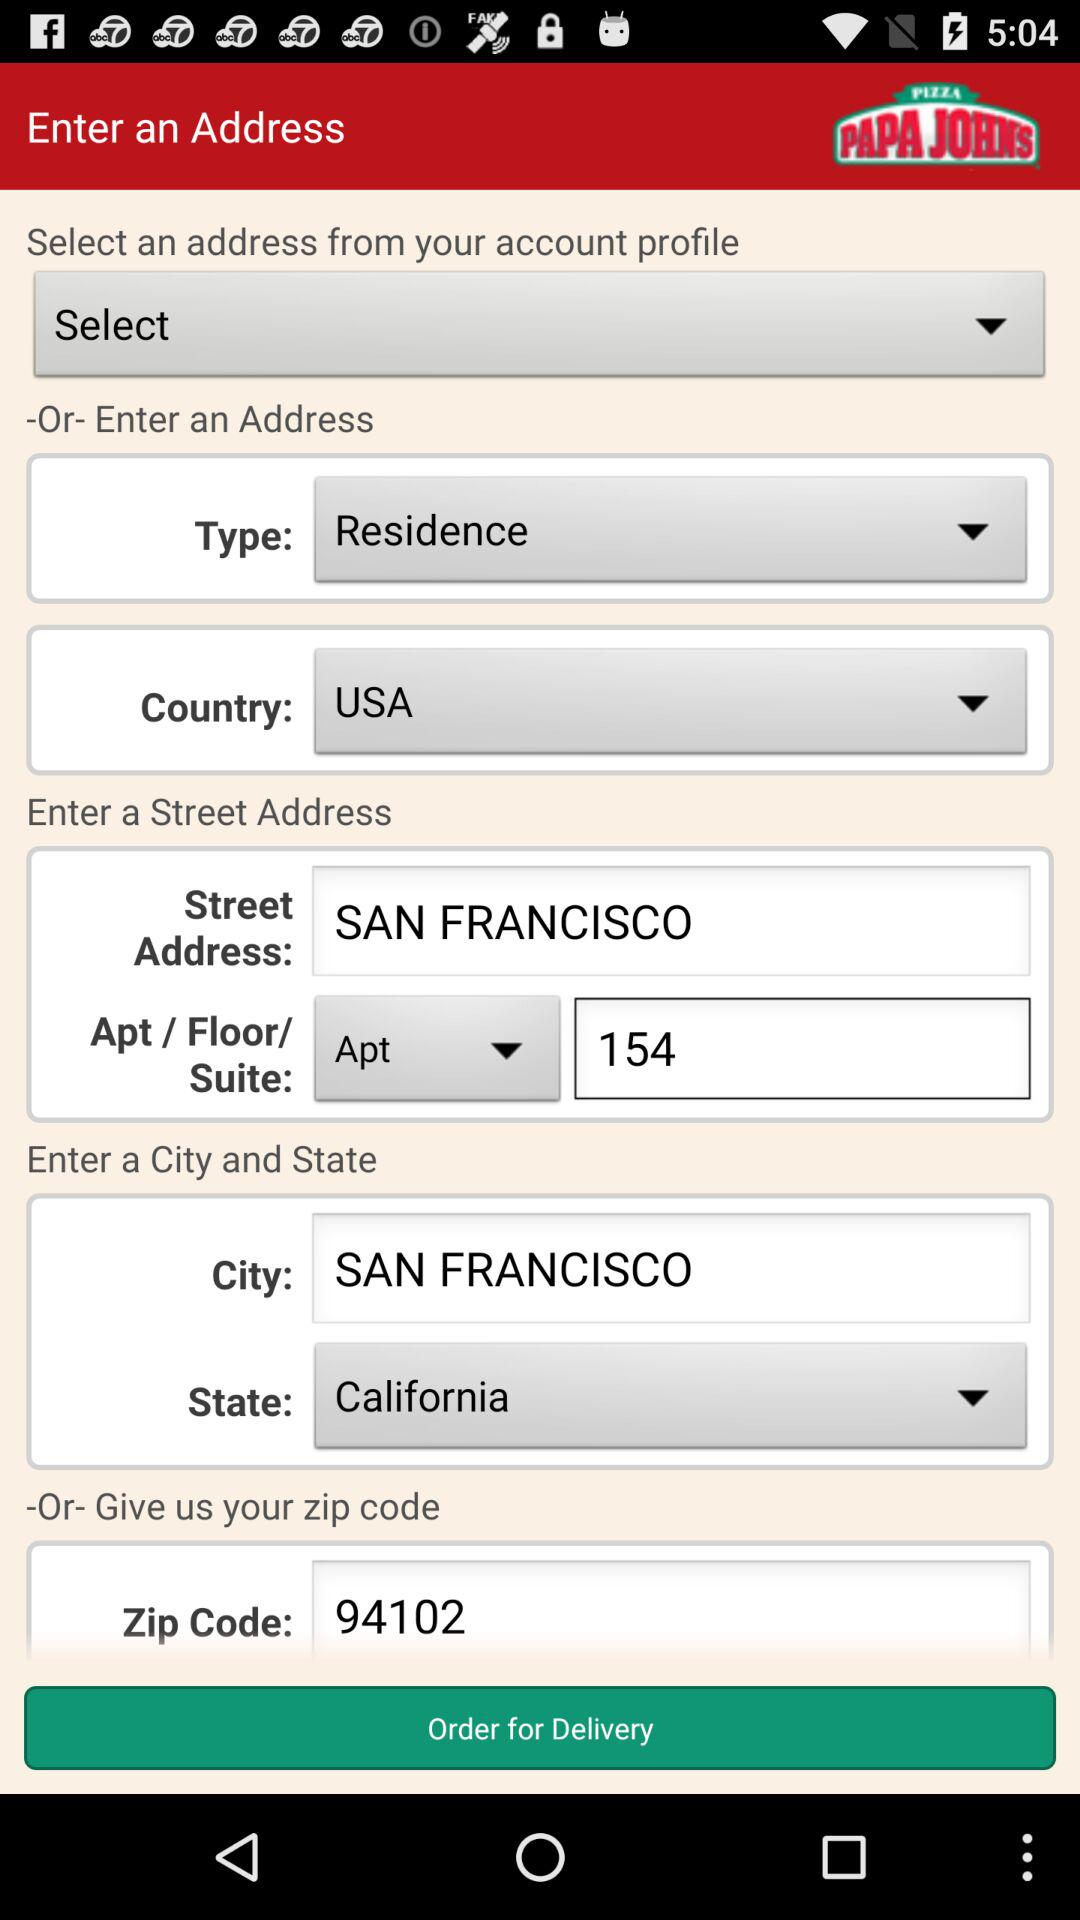What is the apartment number? The apartment number is 154. 